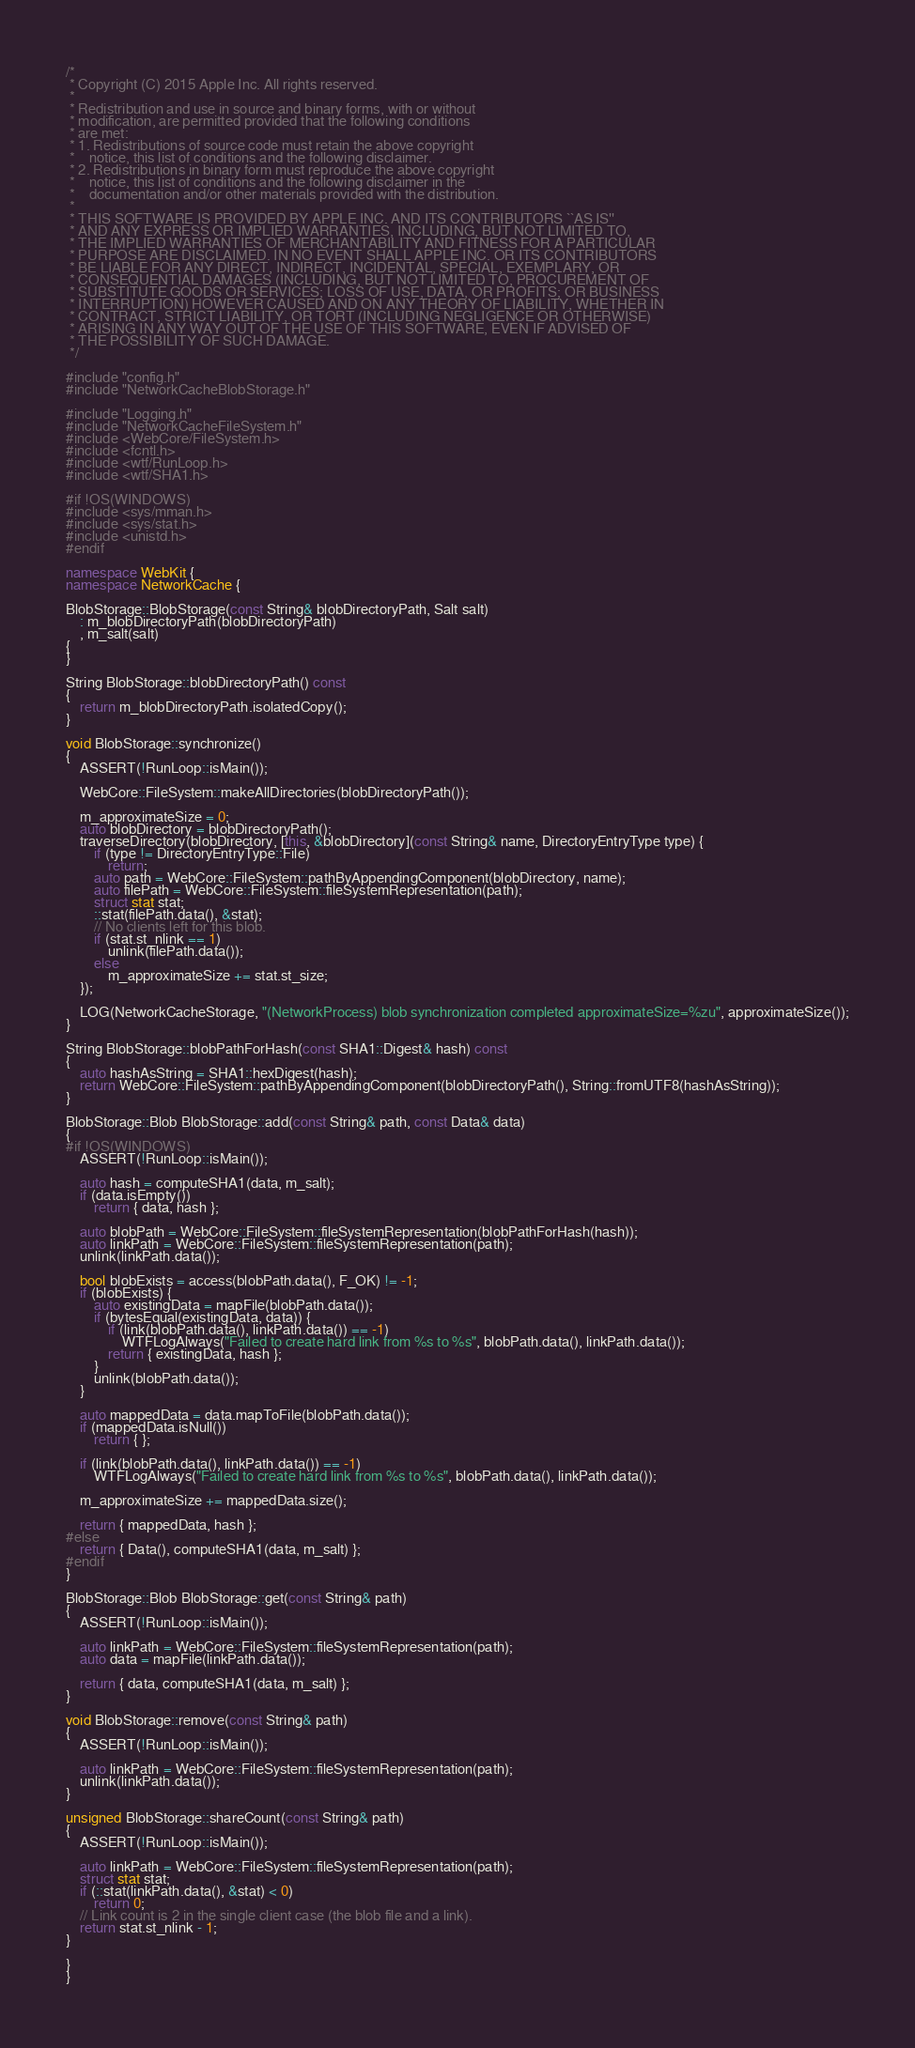<code> <loc_0><loc_0><loc_500><loc_500><_C++_>/*
 * Copyright (C) 2015 Apple Inc. All rights reserved.
 *
 * Redistribution and use in source and binary forms, with or without
 * modification, are permitted provided that the following conditions
 * are met:
 * 1. Redistributions of source code must retain the above copyright
 *    notice, this list of conditions and the following disclaimer.
 * 2. Redistributions in binary form must reproduce the above copyright
 *    notice, this list of conditions and the following disclaimer in the
 *    documentation and/or other materials provided with the distribution.
 *
 * THIS SOFTWARE IS PROVIDED BY APPLE INC. AND ITS CONTRIBUTORS ``AS IS''
 * AND ANY EXPRESS OR IMPLIED WARRANTIES, INCLUDING, BUT NOT LIMITED TO,
 * THE IMPLIED WARRANTIES OF MERCHANTABILITY AND FITNESS FOR A PARTICULAR
 * PURPOSE ARE DISCLAIMED. IN NO EVENT SHALL APPLE INC. OR ITS CONTRIBUTORS
 * BE LIABLE FOR ANY DIRECT, INDIRECT, INCIDENTAL, SPECIAL, EXEMPLARY, OR
 * CONSEQUENTIAL DAMAGES (INCLUDING, BUT NOT LIMITED TO, PROCUREMENT OF
 * SUBSTITUTE GOODS OR SERVICES; LOSS OF USE, DATA, OR PROFITS; OR BUSINESS
 * INTERRUPTION) HOWEVER CAUSED AND ON ANY THEORY OF LIABILITY, WHETHER IN
 * CONTRACT, STRICT LIABILITY, OR TORT (INCLUDING NEGLIGENCE OR OTHERWISE)
 * ARISING IN ANY WAY OUT OF THE USE OF THIS SOFTWARE, EVEN IF ADVISED OF
 * THE POSSIBILITY OF SUCH DAMAGE.
 */

#include "config.h"
#include "NetworkCacheBlobStorage.h"

#include "Logging.h"
#include "NetworkCacheFileSystem.h"
#include <WebCore/FileSystem.h>
#include <fcntl.h>
#include <wtf/RunLoop.h>
#include <wtf/SHA1.h>

#if !OS(WINDOWS)
#include <sys/mman.h>
#include <sys/stat.h>
#include <unistd.h>
#endif

namespace WebKit {
namespace NetworkCache {

BlobStorage::BlobStorage(const String& blobDirectoryPath, Salt salt)
    : m_blobDirectoryPath(blobDirectoryPath)
    , m_salt(salt)
{
}

String BlobStorage::blobDirectoryPath() const
{
    return m_blobDirectoryPath.isolatedCopy();
}

void BlobStorage::synchronize()
{
    ASSERT(!RunLoop::isMain());

    WebCore::FileSystem::makeAllDirectories(blobDirectoryPath());

    m_approximateSize = 0;
    auto blobDirectory = blobDirectoryPath();
    traverseDirectory(blobDirectory, [this, &blobDirectory](const String& name, DirectoryEntryType type) {
        if (type != DirectoryEntryType::File)
            return;
        auto path = WebCore::FileSystem::pathByAppendingComponent(blobDirectory, name);
        auto filePath = WebCore::FileSystem::fileSystemRepresentation(path);
        struct stat stat;
        ::stat(filePath.data(), &stat);
        // No clients left for this blob.
        if (stat.st_nlink == 1)
            unlink(filePath.data());
        else
            m_approximateSize += stat.st_size;
    });

    LOG(NetworkCacheStorage, "(NetworkProcess) blob synchronization completed approximateSize=%zu", approximateSize());
}

String BlobStorage::blobPathForHash(const SHA1::Digest& hash) const
{
    auto hashAsString = SHA1::hexDigest(hash);
    return WebCore::FileSystem::pathByAppendingComponent(blobDirectoryPath(), String::fromUTF8(hashAsString));
}

BlobStorage::Blob BlobStorage::add(const String& path, const Data& data)
{
#if !OS(WINDOWS)
    ASSERT(!RunLoop::isMain());

    auto hash = computeSHA1(data, m_salt);
    if (data.isEmpty())
        return { data, hash };

    auto blobPath = WebCore::FileSystem::fileSystemRepresentation(blobPathForHash(hash));
    auto linkPath = WebCore::FileSystem::fileSystemRepresentation(path);
    unlink(linkPath.data());

    bool blobExists = access(blobPath.data(), F_OK) != -1;
    if (blobExists) {
        auto existingData = mapFile(blobPath.data());
        if (bytesEqual(existingData, data)) {
            if (link(blobPath.data(), linkPath.data()) == -1)
                WTFLogAlways("Failed to create hard link from %s to %s", blobPath.data(), linkPath.data());
            return { existingData, hash };
        }
        unlink(blobPath.data());
    }

    auto mappedData = data.mapToFile(blobPath.data());
    if (mappedData.isNull())
        return { };

    if (link(blobPath.data(), linkPath.data()) == -1)
        WTFLogAlways("Failed to create hard link from %s to %s", blobPath.data(), linkPath.data());

    m_approximateSize += mappedData.size();

    return { mappedData, hash };
#else
    return { Data(), computeSHA1(data, m_salt) };
#endif
}

BlobStorage::Blob BlobStorage::get(const String& path)
{
    ASSERT(!RunLoop::isMain());

    auto linkPath = WebCore::FileSystem::fileSystemRepresentation(path);
    auto data = mapFile(linkPath.data());

    return { data, computeSHA1(data, m_salt) };
}

void BlobStorage::remove(const String& path)
{
    ASSERT(!RunLoop::isMain());

    auto linkPath = WebCore::FileSystem::fileSystemRepresentation(path);
    unlink(linkPath.data());
}

unsigned BlobStorage::shareCount(const String& path)
{
    ASSERT(!RunLoop::isMain());

    auto linkPath = WebCore::FileSystem::fileSystemRepresentation(path);
    struct stat stat;
    if (::stat(linkPath.data(), &stat) < 0)
        return 0;
    // Link count is 2 in the single client case (the blob file and a link).
    return stat.st_nlink - 1;
}

}
}
</code> 